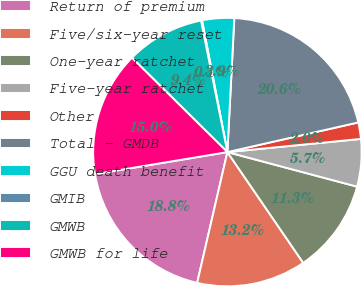Convert chart. <chart><loc_0><loc_0><loc_500><loc_500><pie_chart><fcel>Return of premium<fcel>Five/six-year reset<fcel>One-year ratchet<fcel>Five-year ratchet<fcel>Other<fcel>Total - GMDB<fcel>GGU death benefit<fcel>GMIB<fcel>GMWB<fcel>GMWB for life<nl><fcel>18.76%<fcel>13.17%<fcel>11.3%<fcel>5.71%<fcel>1.98%<fcel>20.63%<fcel>3.85%<fcel>0.12%<fcel>9.44%<fcel>15.03%<nl></chart> 